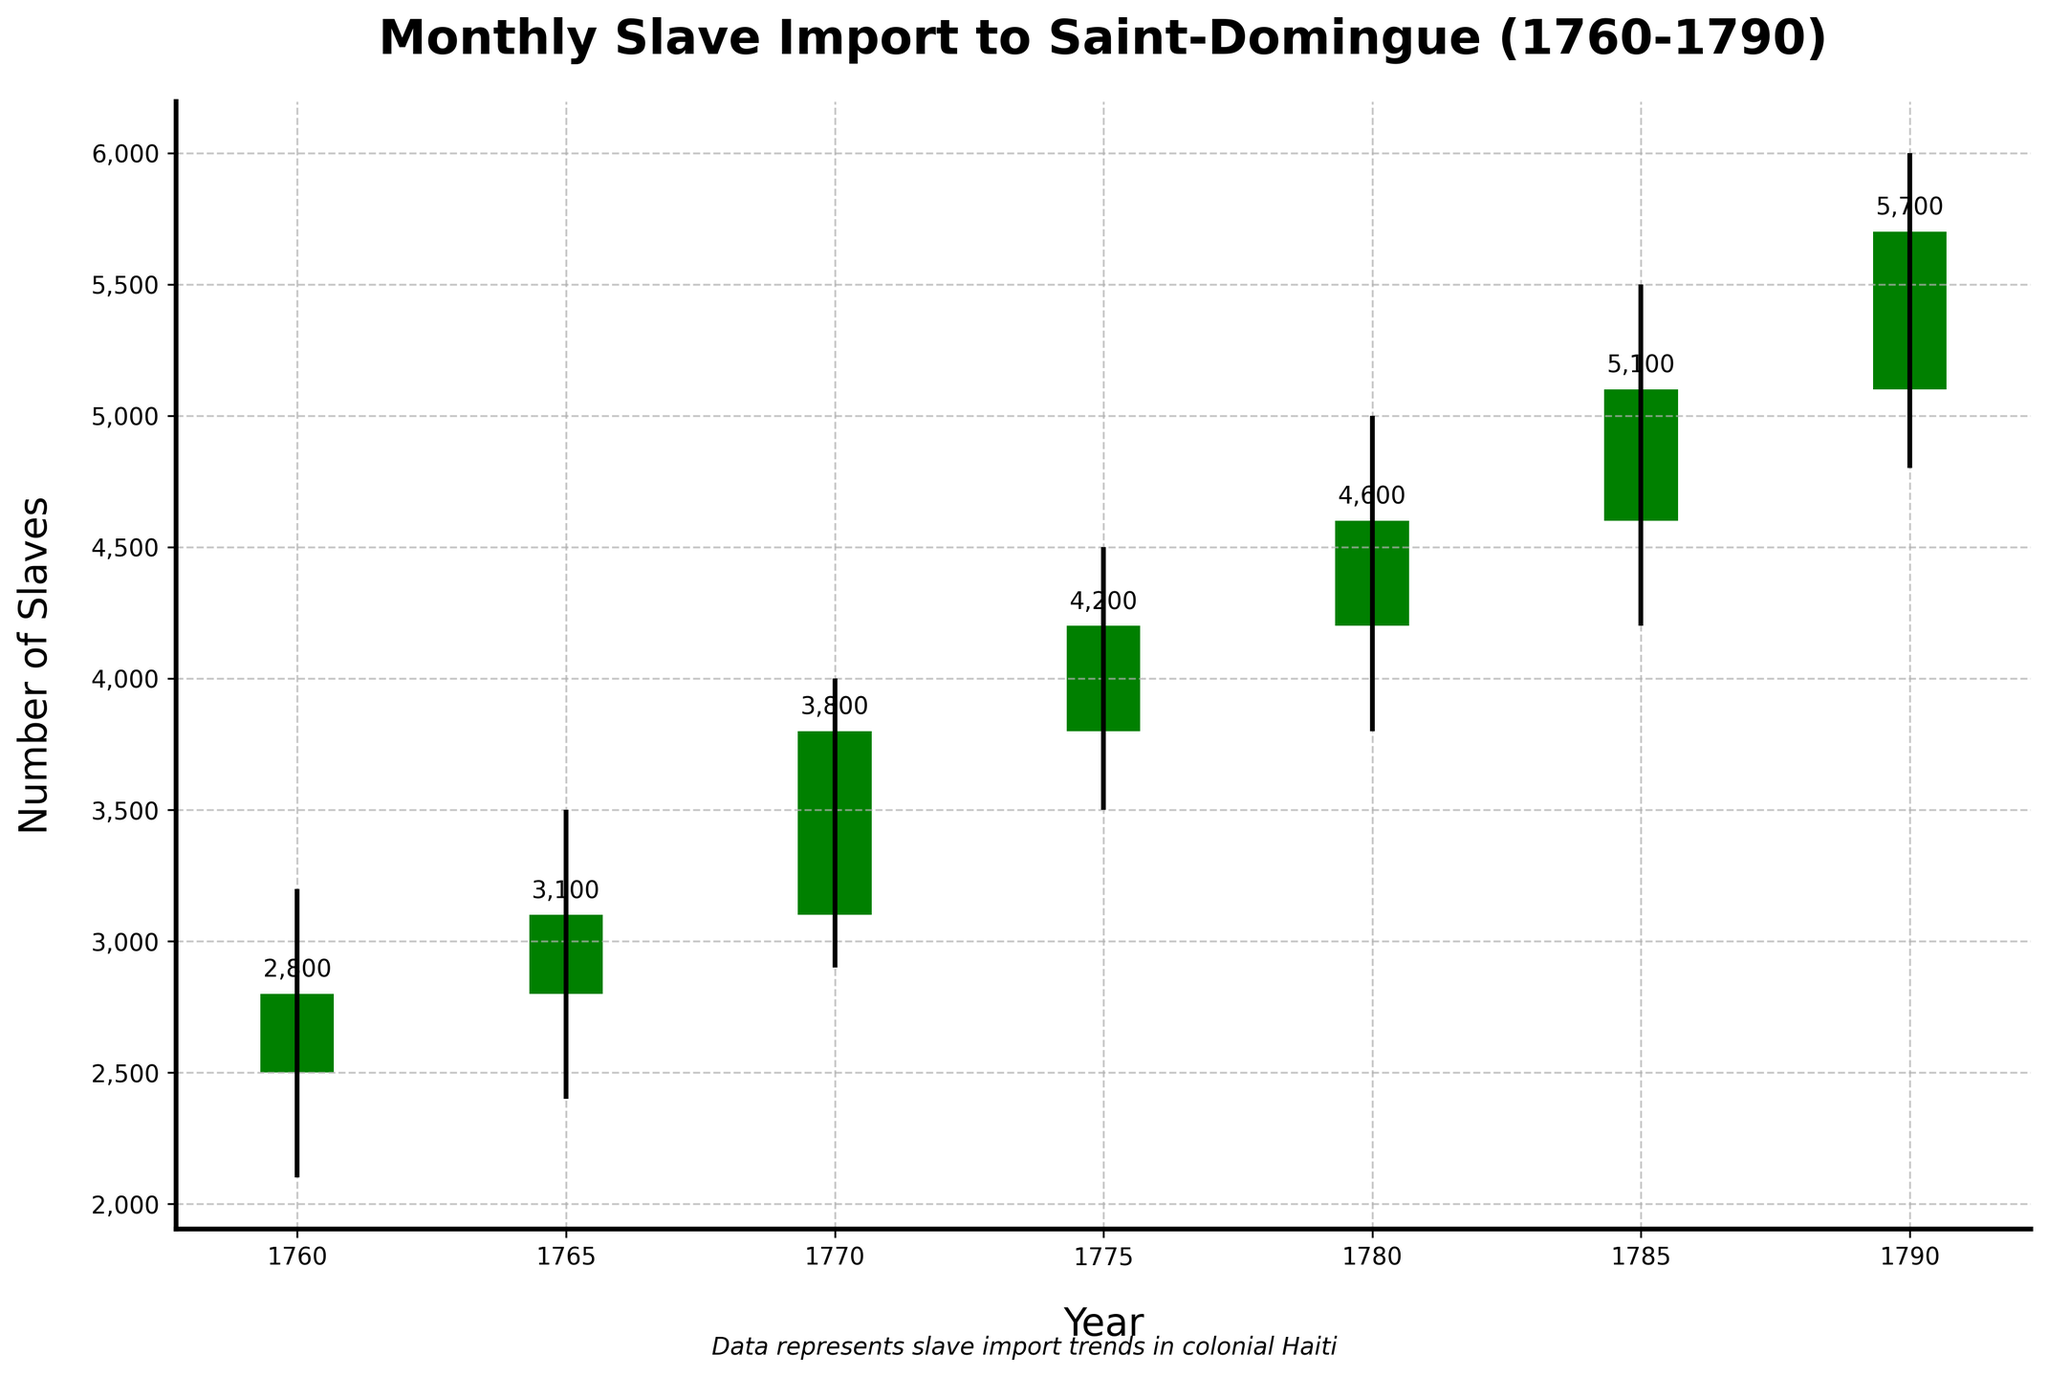What is the title of the figure? The title of the figure is placed at the top and reads "Monthly Slave Import to Saint-Domingue (1760-1790)".
Answer: Monthly Slave Import to Saint-Domingue (1760-1790) What color are the bars where the number of slaves imported increased compared to the opening? The bars where the number of slaves imported increased compared to the opening are green.
Answer: green How many times did the closing values increase compared to the opening values across the given years? Observing the bars, which are green when closing values increase compared to open, there are 7 green bars in total.
Answer: 7 What is the highest number of slaves imported in a single year, as shown in the chart? The highest number of slaves imported in a single year is shown by the highest point on the chart, which has a label of 6000 in 1790.
Answer: 6000 Between which two years did the largest increase in the number of slaves imported occur? The largest increase can be determined by examining the differences in the closing values. The difference from 5100 in 1785 to 5700 in 1790 is the largest, a change of 600.
Answer: Between 1785 and 1790 Which year showed the lowest value for the number of imported slaves? The lowest value is indicated by the lowest point on the chart in 1760, with an annotated value of 2100 under the Low column.
Answer: 1760 What is the average closing value of the number of slaves imported over the given years? Calculate the average by summing all closing values and dividing by the count: (2800 + 3100 + 3800 + 4200 + 4600 + 5100 + 5700) / 7. This sums to 29,300, and dividing by 7 gives 4185.71, rounded to 4185.
Answer: 4185 During which year(s) does the opening value equal the closing value? This scenario would show red or green bars that begin and end at the same point, but none of the bars in the plot fit this condition.
Answer: None What range of values does the y-axis cover? The y-axis values can be determined from the highest and lowest points, ranging from about 2000 to 6000.
Answer: 2000 to 6000 Which year had the least fluctuation in the number of imported slaves, considering the high and low values? The year with the least fluctuation has the smallest range between the high and low. In 1760, this range is the smallest (3200 - 2100 = 1100).
Answer: 1760 